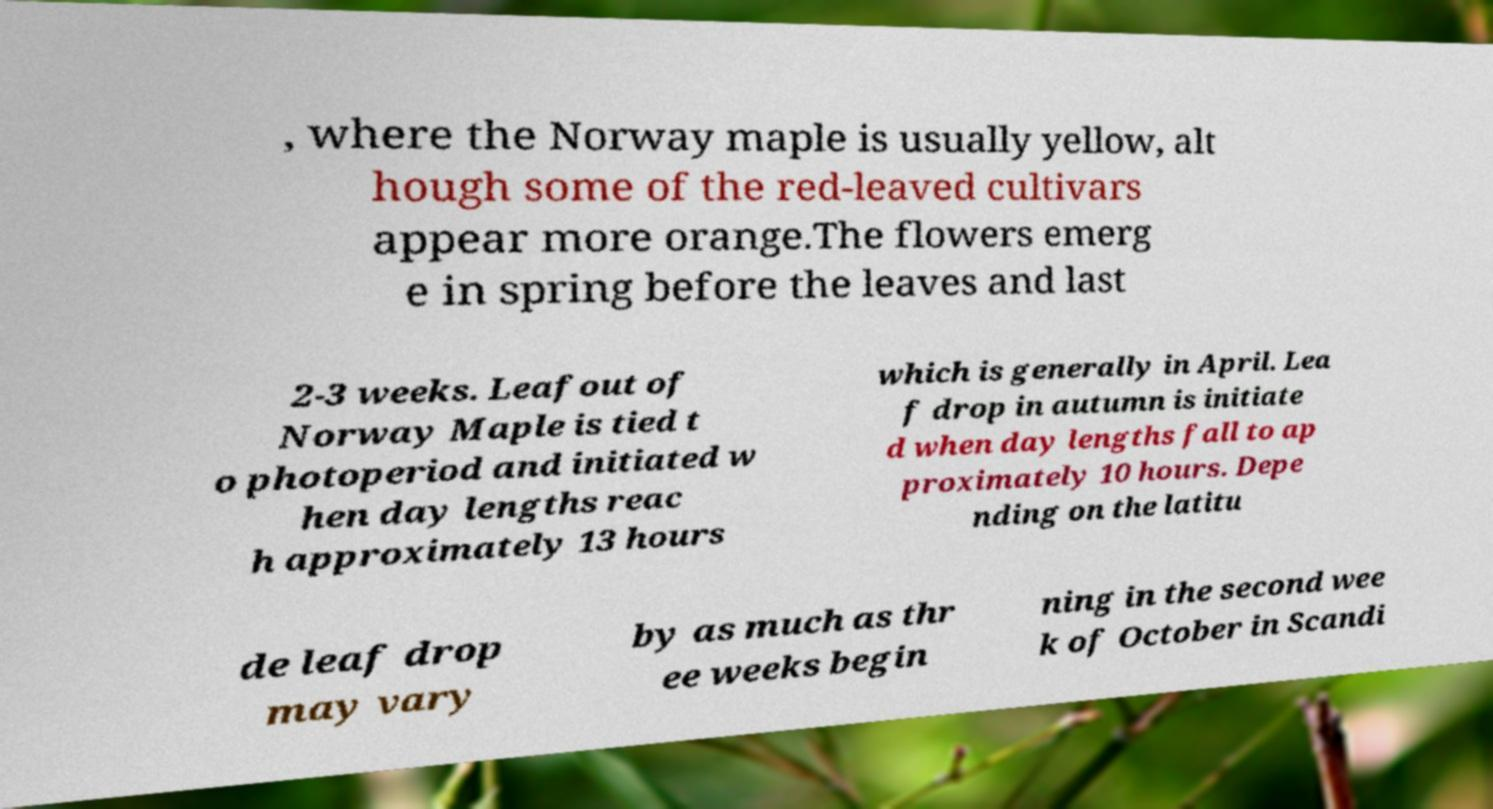There's text embedded in this image that I need extracted. Can you transcribe it verbatim? , where the Norway maple is usually yellow, alt hough some of the red-leaved cultivars appear more orange.The flowers emerg e in spring before the leaves and last 2-3 weeks. Leafout of Norway Maple is tied t o photoperiod and initiated w hen day lengths reac h approximately 13 hours which is generally in April. Lea f drop in autumn is initiate d when day lengths fall to ap proximately 10 hours. Depe nding on the latitu de leaf drop may vary by as much as thr ee weeks begin ning in the second wee k of October in Scandi 